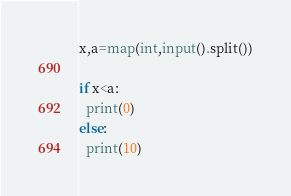Convert code to text. <code><loc_0><loc_0><loc_500><loc_500><_Python_>x,a=map(int,input().split())

if x<a:
  print(0)
else:
  print(10)</code> 